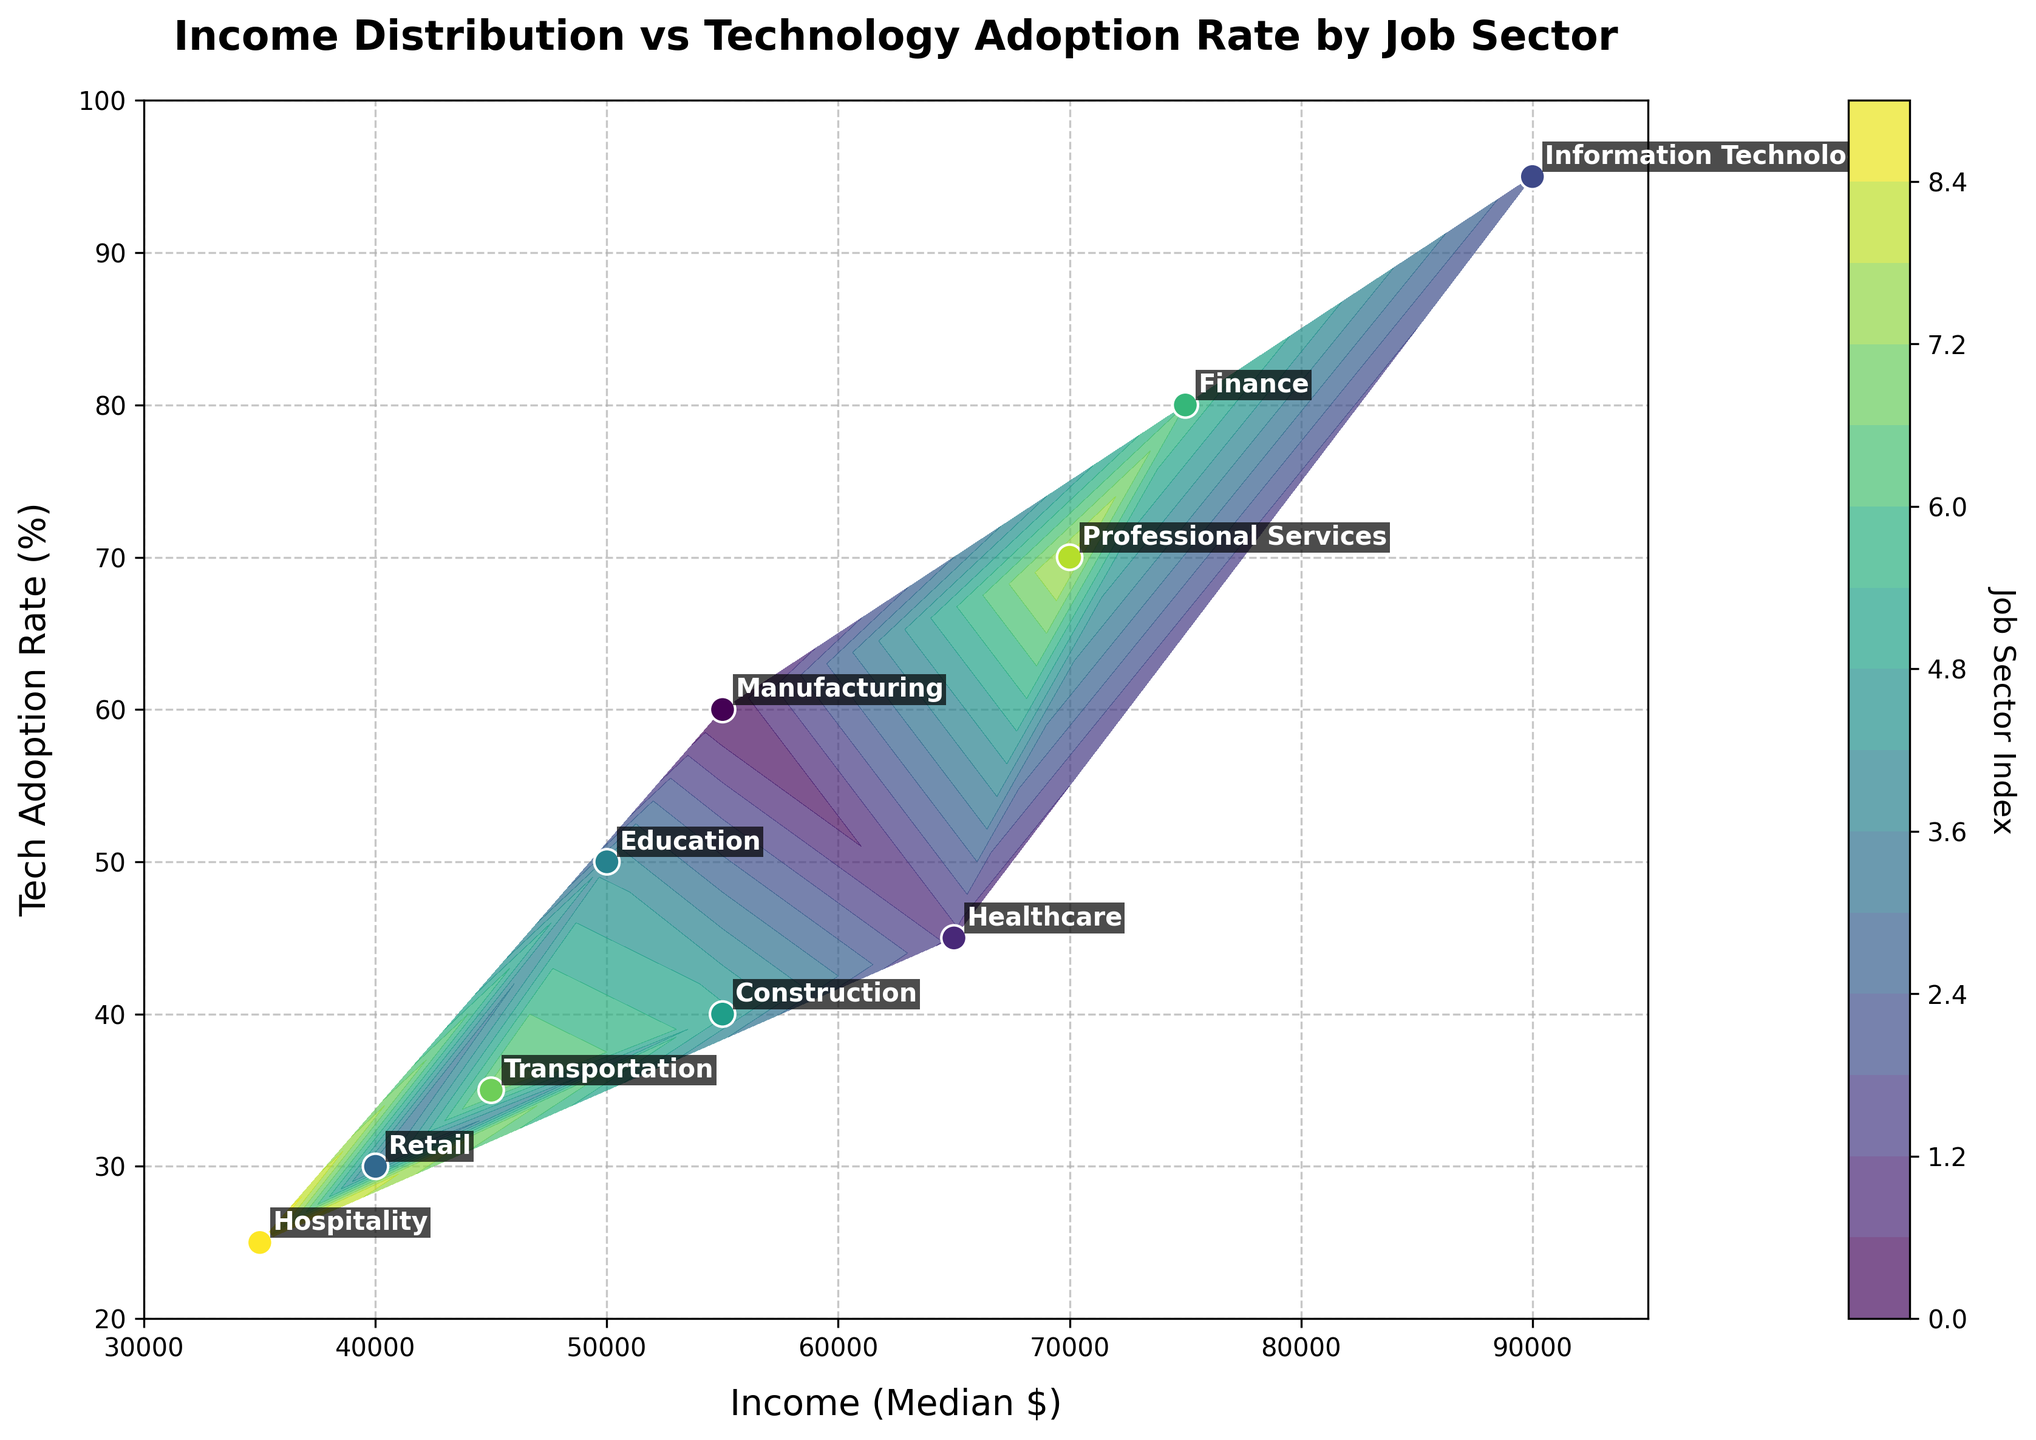What's the job sector with the highest tech adoption rate? The job sector with the highest tech adoption rate can be identified by looking at the Y-axis, which shows the tech adoption rate. The highest value is 95%, which corresponds to the Information Technology sector.
Answer: Information Technology What's the income range on the X-axis? The X-axis of the plot represents the income range. The minimum value is 30000, and the maximum value is 95000.
Answer: 30000 to 95000 Which job sector has a median income of 75000 dollars? To determine which job sector has a median income of 75000 dollars, we look at the label on the X-axis at the value 75000. The corresponding job sector is Finance.
Answer: Finance How do income levels correlate with tech adoption rates in different job sectors? By observing the scatter plot and contour lines, we can see that sectors with higher incomes tend to have higher tech adoption rates. Higher tech adoption rates are particularly evident in sectors like Information Technology and Finance, which are both high-income sectors.
Answer: Higher incomes generally correlate with higher tech adoption rates Which job sectors have a tech adoption rate below 40%? The job sectors with a tech adoption rate below 40% can be identified by looking at points on the Y-axis below 40%. These sectors are Retail (30%), Construction (40%), Transportation (35%), and Hospitality (25%).
Answer: Retail, Construction, Transportation, Hospitality Compare the tech adoption rates of Healthcare and Retail sectors. Healthcare has a tech adoption rate of 45%, while Retail has a 30% tech adoption rate. Comparing these, Healthcare has a higher tech adoption rate.
Answer: Healthcare is higher What is the distribution of income for sectors with a tech adoption rate greater than 70%? Sectors with tech adoption rates greater than 70% include Information Technology (95%), Finance (80%), and Professional Services (70%). Their corresponding incomes are 90000, 75000, and 70000, respectively.
Answer: 70000 to 90000 How is the job sector 'Education' represented in terms of income and tech adoption rate? The Education sector has an income of 50000 dollars and a tech adoption rate of 50%. This can be found by locating the label 'Education' in the plot and referencing its position on the X and Y axes.
Answer: 50000 and 50% Which job sector is closest to having a balanced tech adoption rate and income level? A balanced tech adoption rate and income level would be visually close to the middle of the X and Y axes. The Education sector, with an income of 50000 dollars and a tech adoption rate of 50%, is closest to this balance.
Answer: Education 